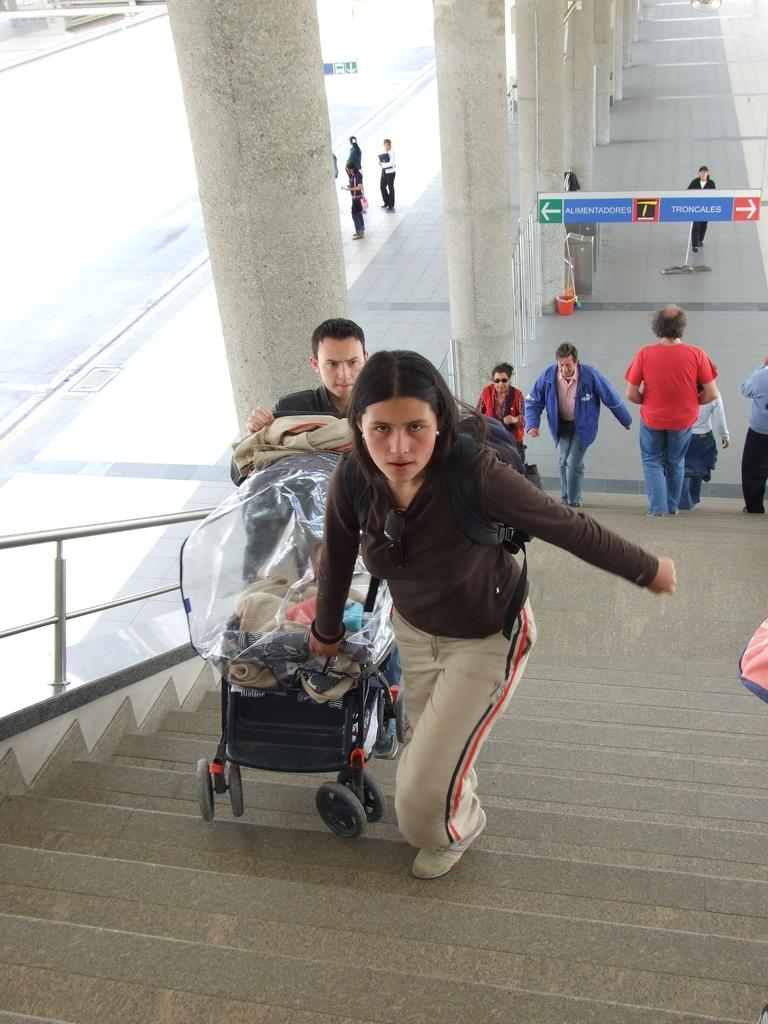Who is present in the image? There is a woman and a man in the image. What are the woman and man doing in the image? The woman and man are carrying a stroller. What can be seen on the right side of the image? There are people on the stairs on the right side of the image. What architectural features are visible in the image? There are pillars visible in the image. What type of truck can be seen in the harbor in the image? There is no truck or harbor present in the image. What kind of humor is being displayed by the woman and man in the image? There is no humor being displayed by the woman and man in the image; they are simply carrying a stroller. 